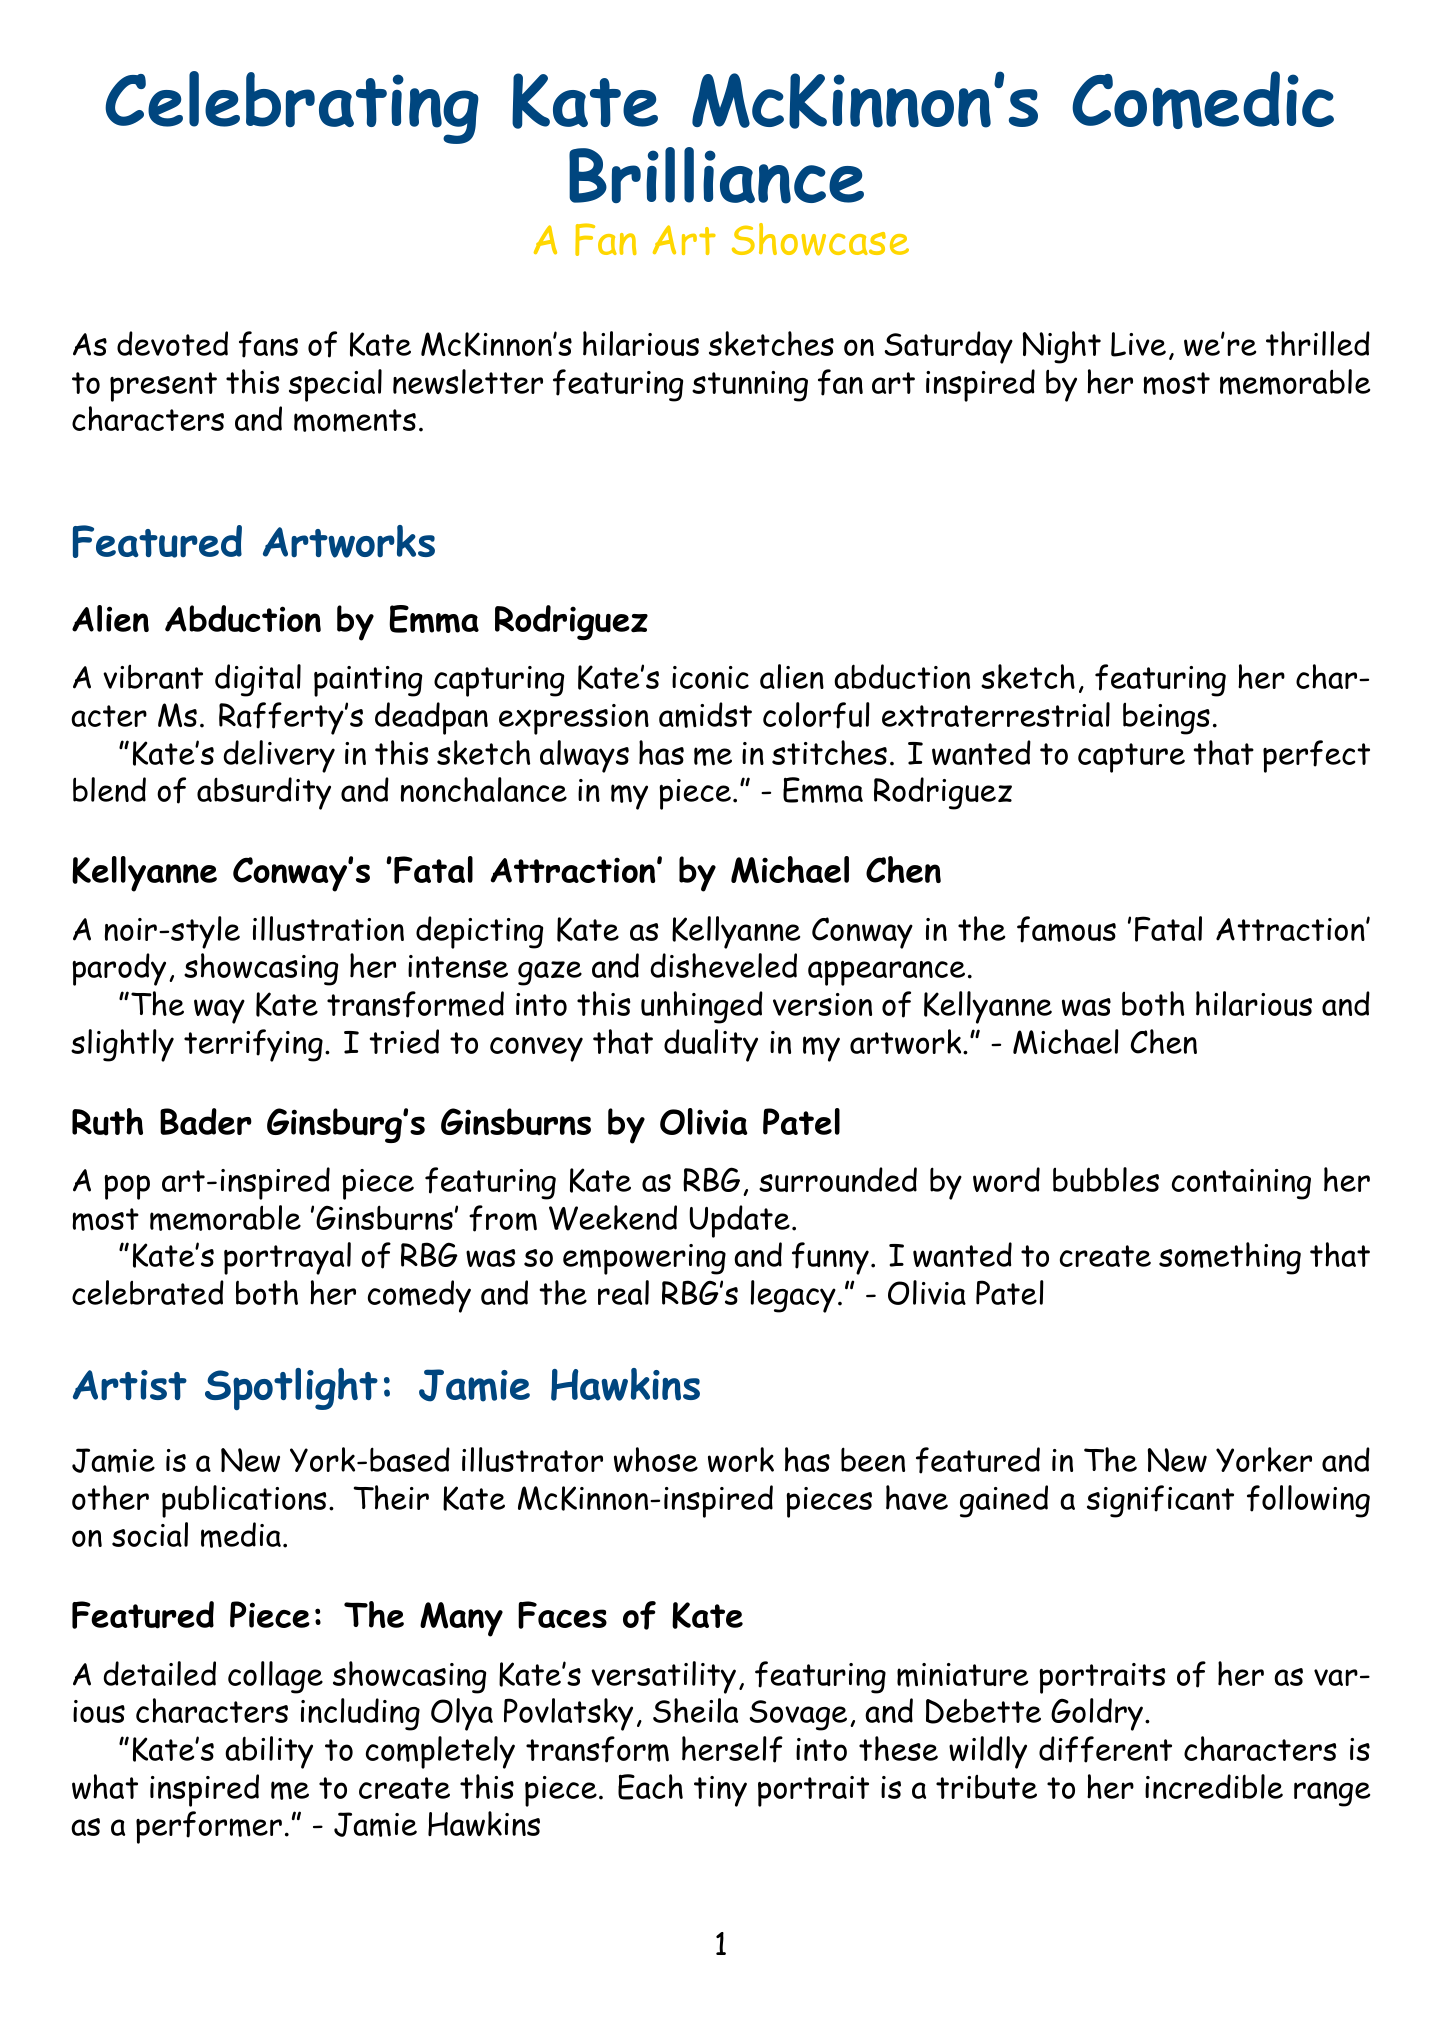What is the title of the newsletter? The title of the newsletter is provided at the beginning of the document.
Answer: Celebrating Kate McKinnon's Comedic Brilliance: A Fan Art Showcase Who created the artwork titled "Alien Abduction"? The artist of "Alien Abduction" is mentioned in the featured artworks section.
Answer: Emma Rodriguez Which character is featured in Olivia Patel's artwork? The description of the artwork indicates the character represented in the piece by Olivia Patel.
Answer: RBG What date is the Virtual Kate McKinnon Fan Art Exhibition scheduled for? The date is explicitly stated in the upcoming events section.
Answer: July 15-22, 2023 What is Jamie Hawkins known for? The bio of Jamie Hawkins explains their accomplishments and recognition in relation to their work.
Answer: Illustrator whose work has been featured in The New Yorker What does the fan poll ask about? The fan poll section explicitly states what the question is about.
Answer: Which Kate McKinnon character would you most like to see immortalized in fan art? What type of workshop is mentioned in the upcoming events? The description of the event indicates the nature of the workshop.
Answer: Sketch Drawing Workshop How can fans submit their own artwork? The call to action section provides information on how submissions can be made.
Answer: Email high-resolution images to katemckinnonart@snlfanclub.com 